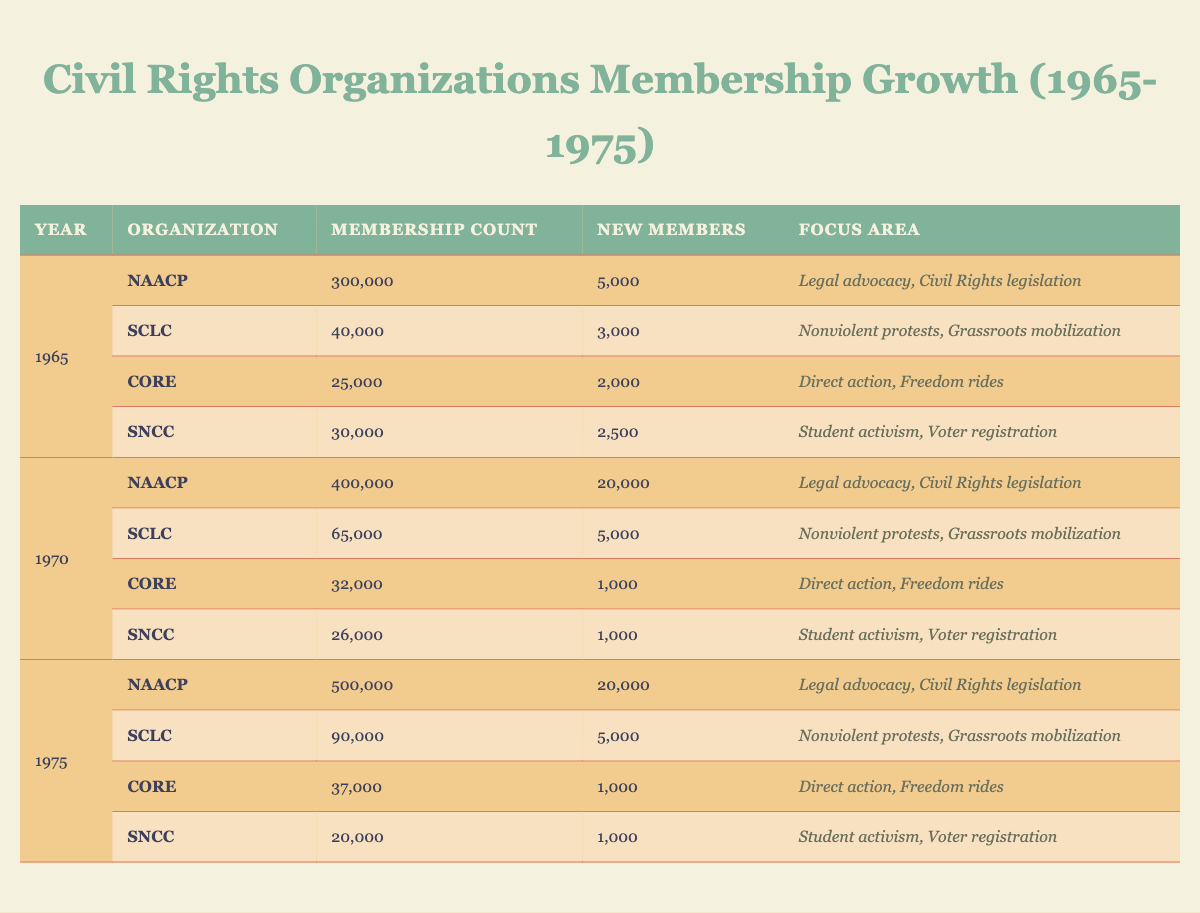What was the membership count of the NAACP in 1970? According to the table, in the year 1970, the membership count of the NAACP is listed as 400,000.
Answer: 400,000 What was the new membership count of SCLC in 1966? The table indicates that in 1966, SCLC gained 5,000 new members.
Answer: 5,000 Which organization had the highest membership count in 1975? In 1975, the NAACP had the highest membership count with 500,000, compared to the other organizations.
Answer: NAACP What was the total membership count of CORE from 1965 to 1975? The membership counts for CORE are: 25,000 (1965), 27,000 (1966), 28,000 (1967), 30,000 (1968), 31,000 (1969), 32,000 (1970), 33,000 (1971), 34,000 (1972), 35,000 (1973), 36,000 (1974), 37,000 (1975). Adding these values together (25,000 + 27,000 + 28,000 + 30,000 + 31,000 + 32,000 + 33,000 + 34,000 + 35,000 + 36,000 + 37,000) gives us a total of  392,000.
Answer: 392,000 What was the average new member growth of SNCC from 1965 to 1975? The new members for SNCC are: 2,500 (1965), 1,000 (1966), 2,000 (1967), 1,000 (1968), 1,000 (1969), 1,000 (1970), 1,000 (1971), 1,000 (1972), 1,000 (1973), 1,000 (1974), 1,000 (1975). The total new members is 2,500 + 1,000*10 = 12,500. There are 11 years of data, so the average is 12,500 / 11 = 1,136.36.
Answer: Approximately 1,136 Did the membership of SCLC steadily increase every year from 1965 to 1975? By reviewing the table, SCLC's membership numbers are: 40,000 (1965), 45,000 (1966), 50,000 (1967), 55,000 (1968), 60,000 (1969), 65,000 (1970), 70,000 (1971), 75,000 (1972), 80,000 (1973), 85,000 (1974), and 90,000 (1975), which shows a consistent increase each year. Thus, the answer is yes.
Answer: Yes Which organization experienced the most significant percentage increase in membership from 1965 to 1975? To determine this, we can calculate the percentage increase for each organization over this period. NAACP: ((500,000 - 300,000) / 300,000) * 100 = 66.67%. SCLC: ((90,000 - 40,000) / 40,000) * 100 = 125%. CORE: ((37,000 - 25,000) / 25,000) * 100 = 48%. SNCC: ((20,000 - 30,000) / 30,000) * 100 = -33.33%. Comparing these, SCLC had the highest percentage increase.
Answer: SCLC What was the total new member growth for NAACP from 1965 to 1975? The new member counts for NAACP are: 5,000 (1965), 20,000 (1966), 20,000 (1967), 20,000 (1968), 20,000 (1969), 20,000 (1970), 20,000 (1971), 20,000 (1972), 20,000 (1973), 20,000 (1974), and 20,000 (1975). Summing these values: 5,000 + 20,000*10 = 205,000.
Answer: 205,000 In which year did SNCC have the lowest membership count? Looking at the membership count for SNCC over the years: 30,000 (1965), 31,000 (1966), 29,000 (1967), 28,000 (1968), 27,000 (1969), 26,000 (1970), 25,000 (1971), 24,000 (1972), 23,000 (1973), 22,000 (1974), 20,000 (1975). The lowest membership count is 20,000 in 1975.
Answer: 1975 Which organization had the same number of new members in both 1967 and 1978? The table shows that CORE had 1,000 new members in both 1967 and 1978.
Answer: CORE 